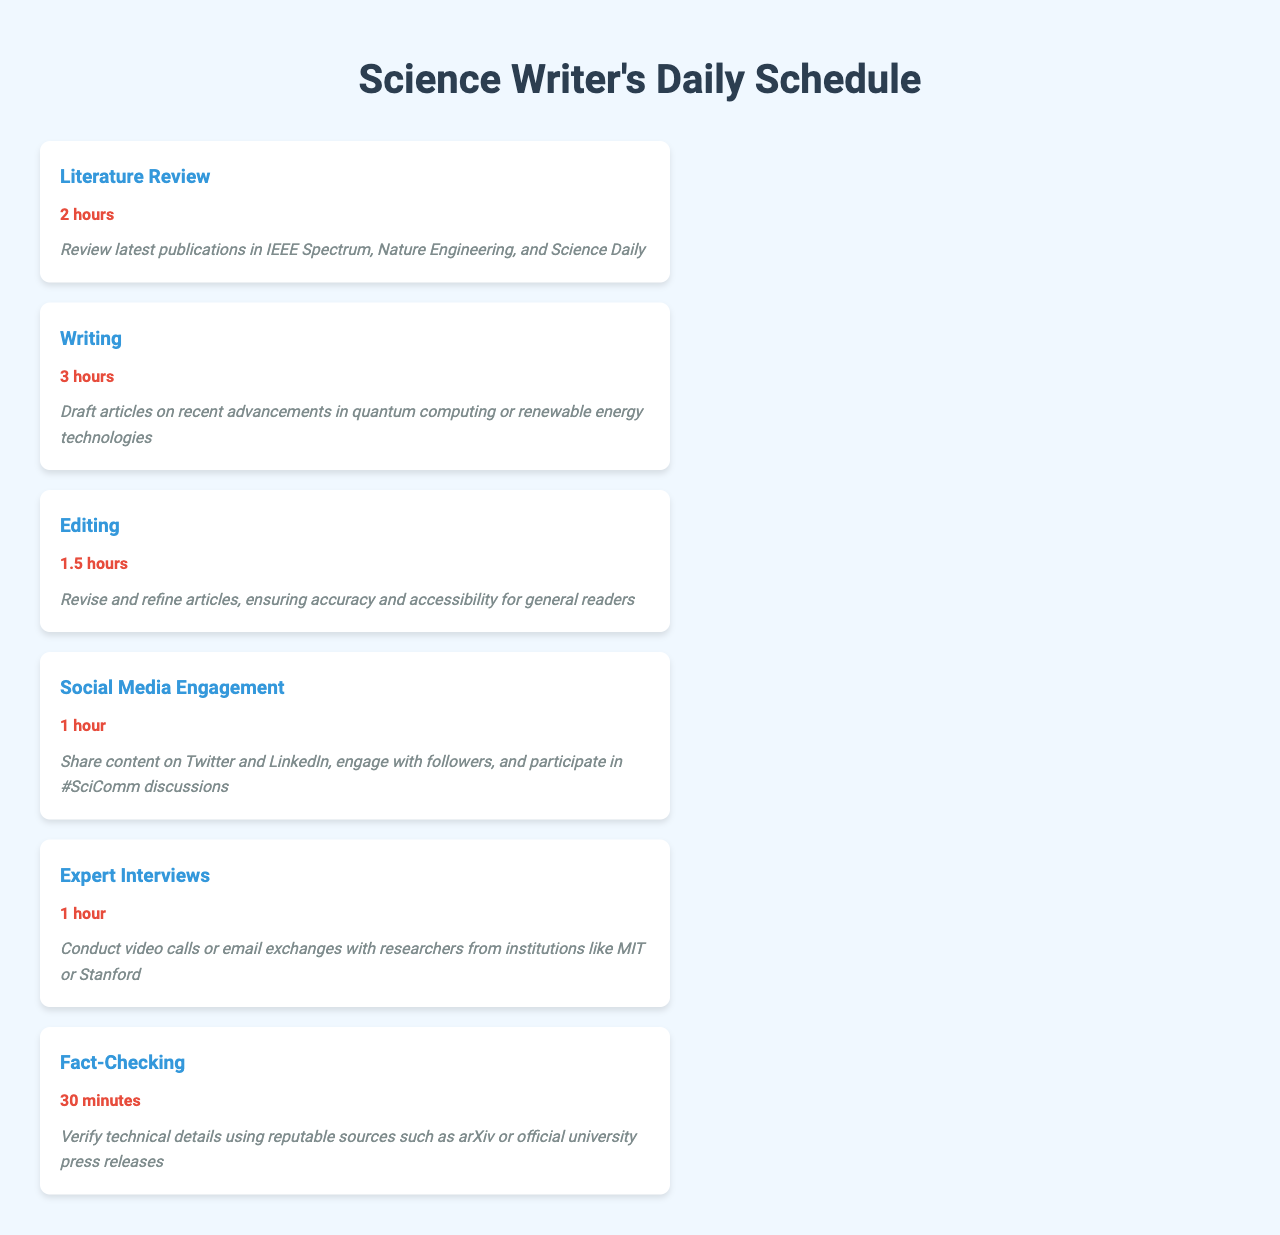What is the total time allocated for literature review? The total time for literature review is given as 2 hours in the schedule.
Answer: 2 hours What task has the longest time allocation? In the schedule, writing is allocated the most time at 3 hours.
Answer: Writing How much time is dedicated to social media engagement? The document specifies that 1 hour is allocated for social media engagement.
Answer: 1 hour What is the total time spent on editing and fact-checking combined? The total time for editing (1.5 hours) and fact-checking (30 minutes) adds up to 2 hours.
Answer: 2 hours Which publication is mentioned for the literature review? The document lists IEEE Spectrum as one of the publications for literature review.
Answer: IEEE Spectrum How many tasks are scheduled for the day? The document outlines a total of 6 tasks in the daily schedule.
Answer: 6 tasks What is the primary focus of the writing task? The writing task focuses on advancements in quantum computing or renewable energy technologies.
Answer: Recent advancements in quantum computing or renewable energy technologies Which institutions are mentioned for expert interviews? The document specifies conducting interviews with researchers from MIT or Stanford.
Answer: MIT or Stanford What is the duration of fact-checking? The schedule indicates that the duration for fact-checking is 30 minutes.
Answer: 30 minutes 